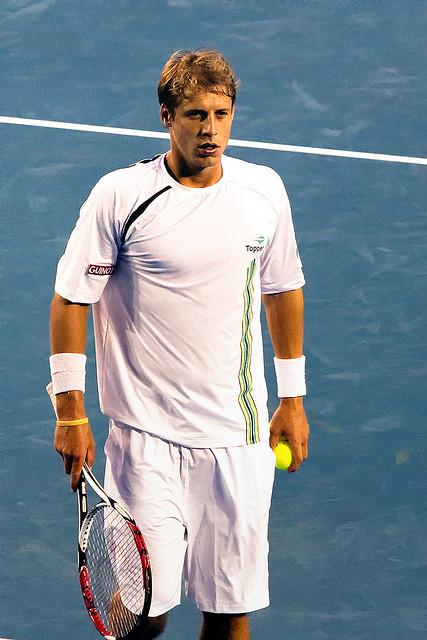Why does he have his forearms wrapped?

Choices:
A) is injured
B) to strengthen
C) keep on
D) showing off to strengthen 